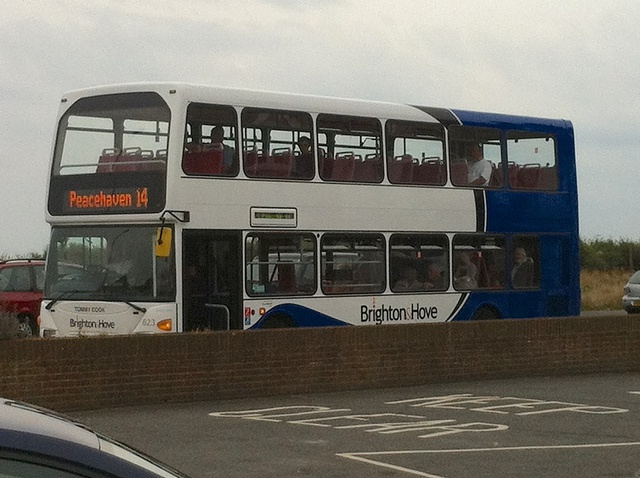Describe the objects in this image and their specific colors. I can see bus in lightgray, black, darkgray, and gray tones, car in lightgray, black, darkgray, and gray tones, car in lightgray, gray, black, and maroon tones, people in lightgray, black, and gray tones, and people in lightgray, gray, and black tones in this image. 